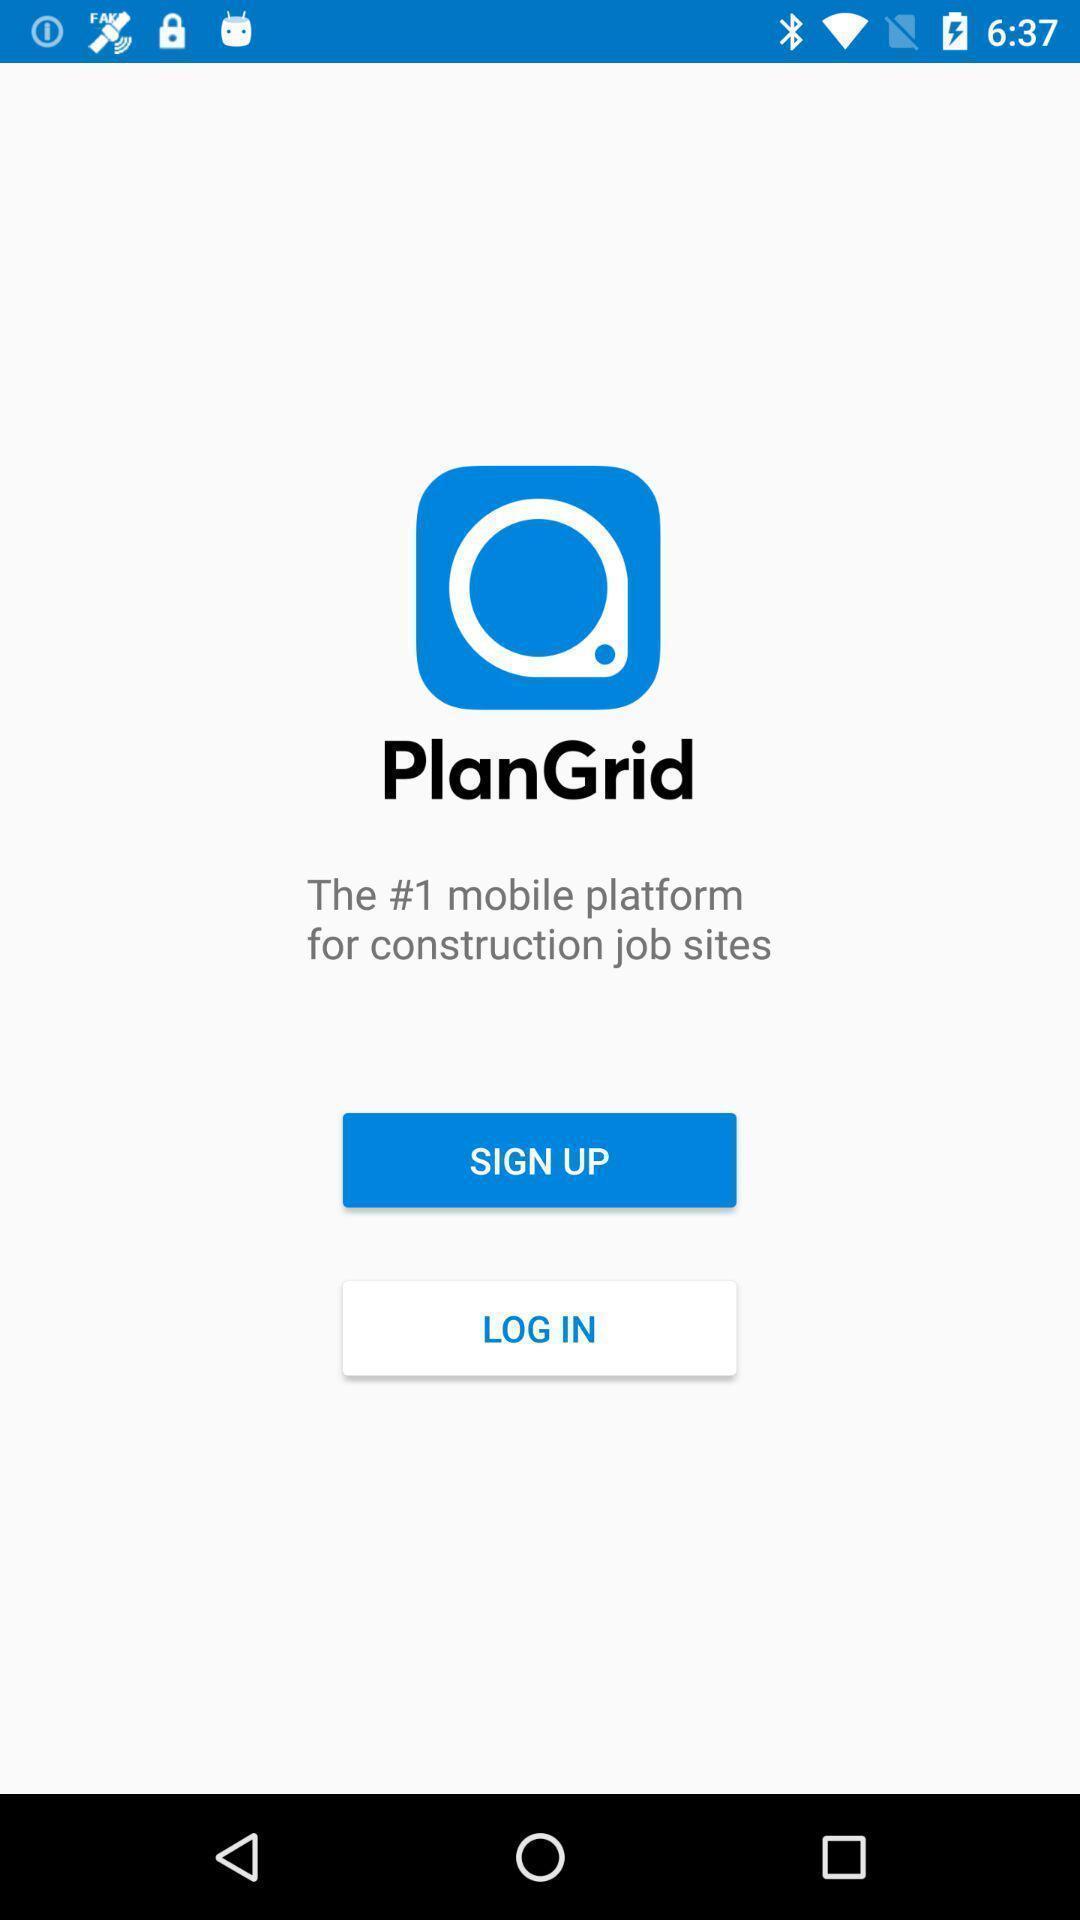What can you discern from this picture? Welcome page of a social app. 